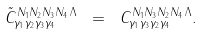<formula> <loc_0><loc_0><loc_500><loc_500>\tilde { C } ^ { N _ { 1 } N _ { 2 } N _ { 3 } N _ { 4 } \, \Lambda } _ { \gamma _ { 1 } \gamma _ { 2 } \gamma _ { 3 } \gamma _ { 4 } } \ = \ C ^ { N _ { 1 } N _ { 3 } N _ { 2 } N _ { 4 } \, \Lambda } _ { \gamma _ { 1 } \gamma _ { 3 } \gamma _ { 2 } \gamma _ { 4 } } .</formula> 